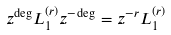<formula> <loc_0><loc_0><loc_500><loc_500>z ^ { \deg } L _ { 1 } ^ { ( r ) } z ^ { - \deg } = z ^ { - r } L _ { 1 } ^ { ( r ) }</formula> 